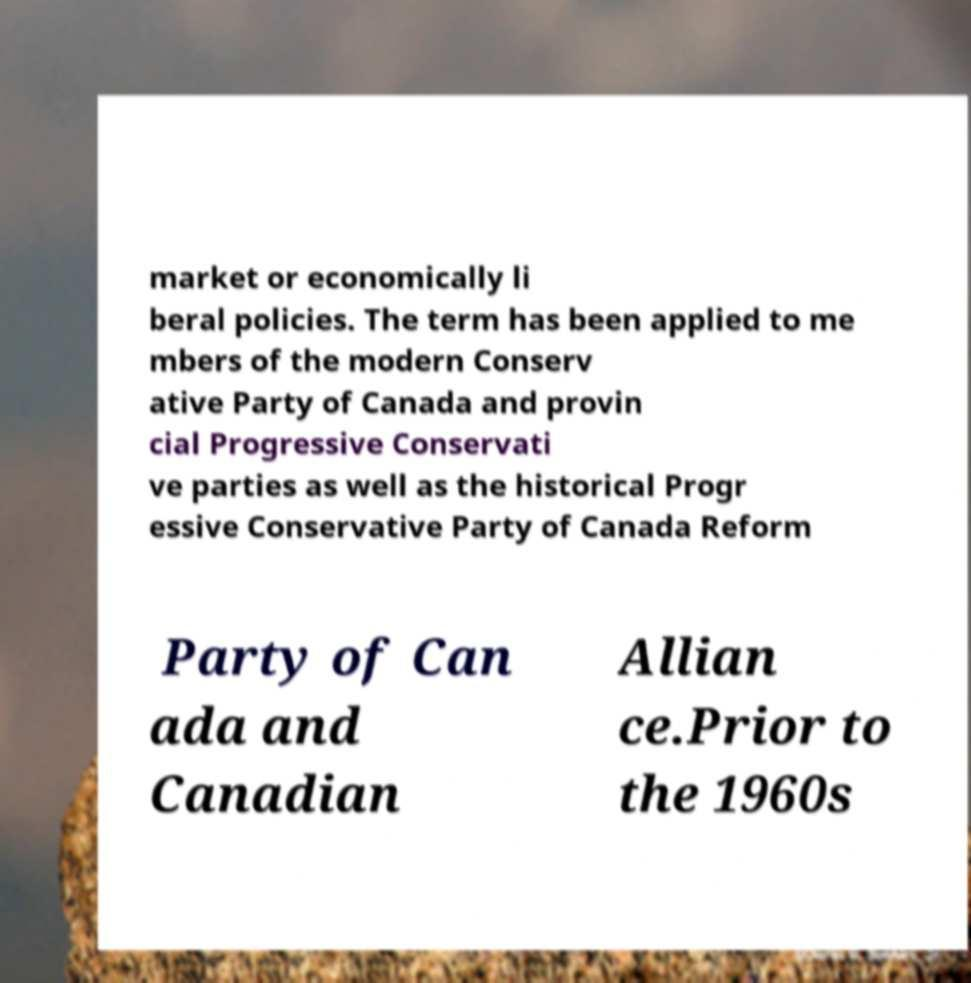Could you assist in decoding the text presented in this image and type it out clearly? market or economically li beral policies. The term has been applied to me mbers of the modern Conserv ative Party of Canada and provin cial Progressive Conservati ve parties as well as the historical Progr essive Conservative Party of Canada Reform Party of Can ada and Canadian Allian ce.Prior to the 1960s 